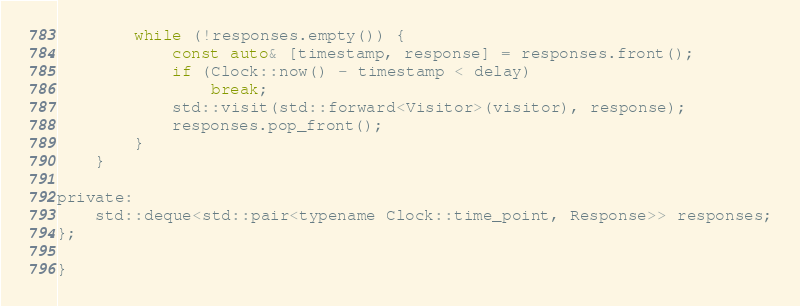Convert code to text. <code><loc_0><loc_0><loc_500><loc_500><_C_>        while (!responses.empty()) {
            const auto& [timestamp, response] = responses.front();
            if (Clock::now() - timestamp < delay)
                break;
            std::visit(std::forward<Visitor>(visitor), response);
            responses.pop_front();
        }
    }

private:
    std::deque<std::pair<typename Clock::time_point, Response>> responses;
};

}
</code> 